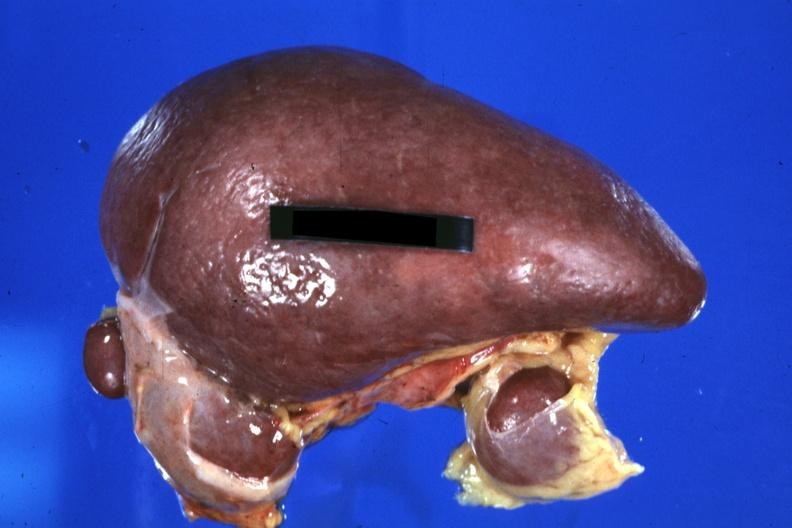s history present?
Answer the question using a single word or phrase. No 